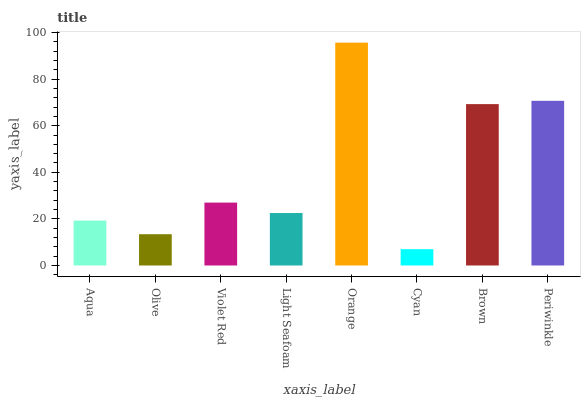Is Cyan the minimum?
Answer yes or no. Yes. Is Orange the maximum?
Answer yes or no. Yes. Is Olive the minimum?
Answer yes or no. No. Is Olive the maximum?
Answer yes or no. No. Is Aqua greater than Olive?
Answer yes or no. Yes. Is Olive less than Aqua?
Answer yes or no. Yes. Is Olive greater than Aqua?
Answer yes or no. No. Is Aqua less than Olive?
Answer yes or no. No. Is Violet Red the high median?
Answer yes or no. Yes. Is Light Seafoam the low median?
Answer yes or no. Yes. Is Cyan the high median?
Answer yes or no. No. Is Periwinkle the low median?
Answer yes or no. No. 